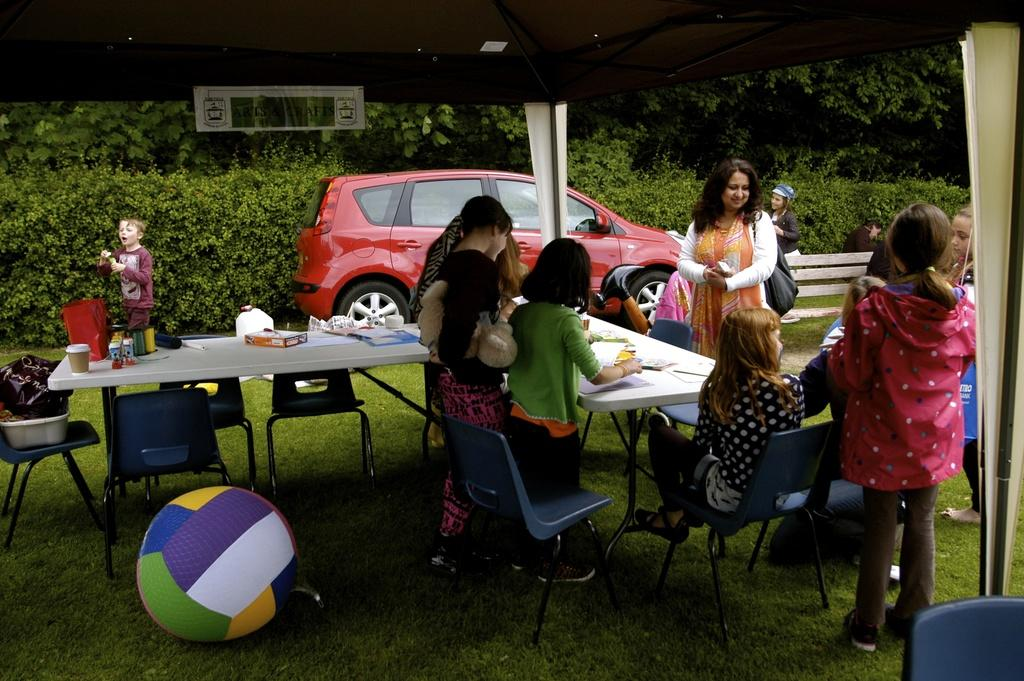What can be seen in the image involving children? There are children standing in the image. What is the woman doing in the image? There is a woman standing over a child in the image. What can be seen in the background of the image? There is a car, trees, a table, and a ball in the background of the image. How many ladybugs are crawling on the children's fingers in the image? There are no ladybugs present in the image, and the children's fingers are not visible. What type of line is drawn on the table in the image? There is no line drawn on the table in the image. 